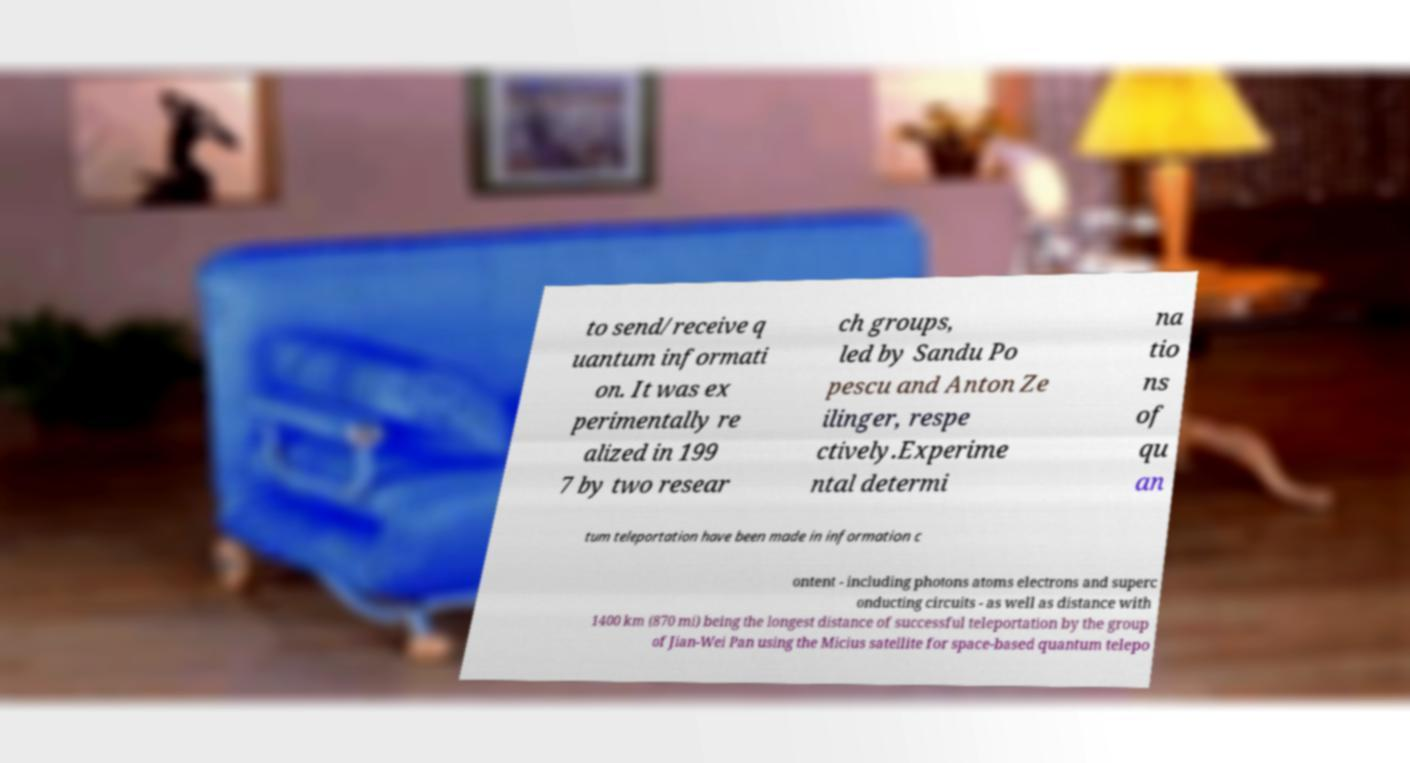Can you read and provide the text displayed in the image?This photo seems to have some interesting text. Can you extract and type it out for me? to send/receive q uantum informati on. It was ex perimentally re alized in 199 7 by two resear ch groups, led by Sandu Po pescu and Anton Ze ilinger, respe ctively.Experime ntal determi na tio ns of qu an tum teleportation have been made in information c ontent - including photons atoms electrons and superc onducting circuits - as well as distance with 1400 km (870 mi) being the longest distance of successful teleportation by the group of Jian-Wei Pan using the Micius satellite for space-based quantum telepo 